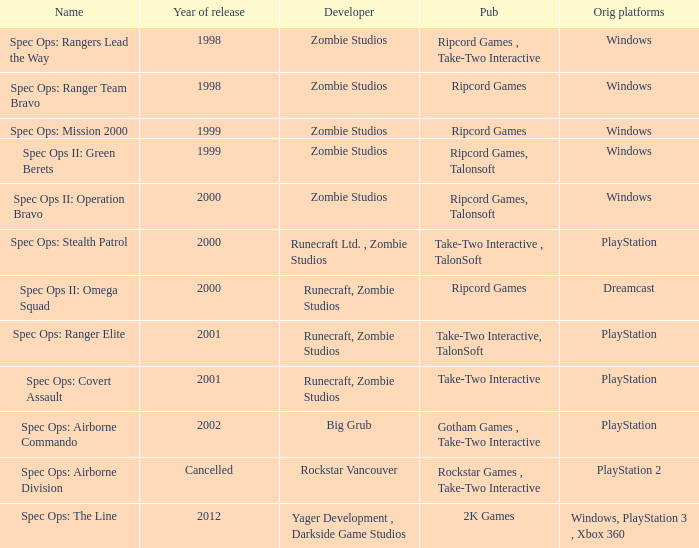Could you parse the entire table? {'header': ['Name', 'Year of release', 'Developer', 'Pub', 'Orig platforms'], 'rows': [['Spec Ops: Rangers Lead the Way', '1998', 'Zombie Studios', 'Ripcord Games , Take-Two Interactive', 'Windows'], ['Spec Ops: Ranger Team Bravo', '1998', 'Zombie Studios', 'Ripcord Games', 'Windows'], ['Spec Ops: Mission 2000', '1999', 'Zombie Studios', 'Ripcord Games', 'Windows'], ['Spec Ops II: Green Berets', '1999', 'Zombie Studios', 'Ripcord Games, Talonsoft', 'Windows'], ['Spec Ops II: Operation Bravo', '2000', 'Zombie Studios', 'Ripcord Games, Talonsoft', 'Windows'], ['Spec Ops: Stealth Patrol', '2000', 'Runecraft Ltd. , Zombie Studios', 'Take-Two Interactive , TalonSoft', 'PlayStation'], ['Spec Ops II: Omega Squad', '2000', 'Runecraft, Zombie Studios', 'Ripcord Games', 'Dreamcast'], ['Spec Ops: Ranger Elite', '2001', 'Runecraft, Zombie Studios', 'Take-Two Interactive, TalonSoft', 'PlayStation'], ['Spec Ops: Covert Assault', '2001', 'Runecraft, Zombie Studios', 'Take-Two Interactive', 'PlayStation'], ['Spec Ops: Airborne Commando', '2002', 'Big Grub', 'Gotham Games , Take-Two Interactive', 'PlayStation'], ['Spec Ops: Airborne Division', 'Cancelled', 'Rockstar Vancouver', 'Rockstar Games , Take-Two Interactive', 'PlayStation 2'], ['Spec Ops: The Line', '2012', 'Yager Development , Darkside Game Studios', '2K Games', 'Windows, PlayStation 3 , Xbox 360']]} Which publisher is responsible for spec ops: stealth patrol? Take-Two Interactive , TalonSoft. 